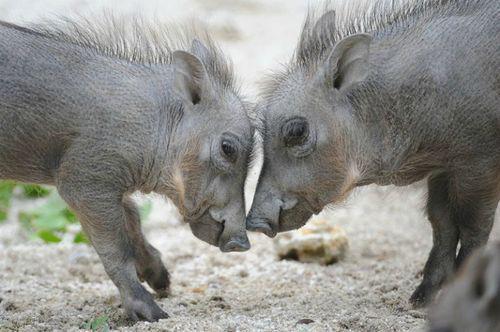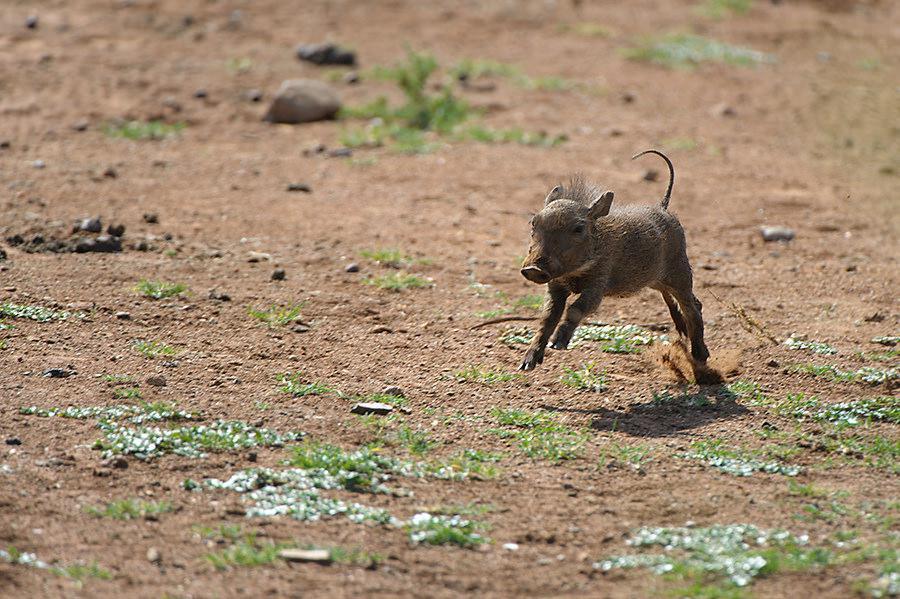The first image is the image on the left, the second image is the image on the right. For the images shown, is this caption "There are two hogs facing each other in one of the images." true? Answer yes or no. Yes. The first image is the image on the left, the second image is the image on the right. Assess this claim about the two images: "The lefthand image contains one young warthog, and the righthand image contains two young warthogs.". Correct or not? Answer yes or no. No. 